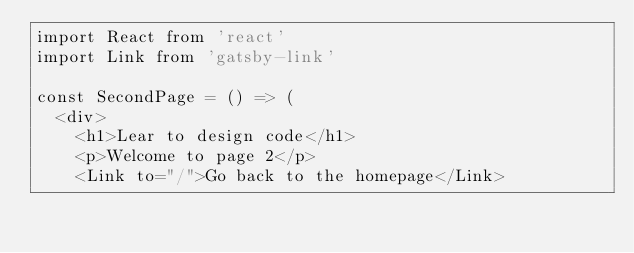Convert code to text. <code><loc_0><loc_0><loc_500><loc_500><_JavaScript_>import React from 'react'
import Link from 'gatsby-link'

const SecondPage = () => (
  <div>
    <h1>Lear to design code</h1>
    <p>Welcome to page 2</p>
    <Link to="/">Go back to the homepage</Link></code> 